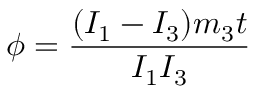<formula> <loc_0><loc_0><loc_500><loc_500>\phi = \frac { ( I _ { 1 } - I _ { 3 } ) m _ { 3 } t } { I _ { 1 } I _ { 3 } }</formula> 